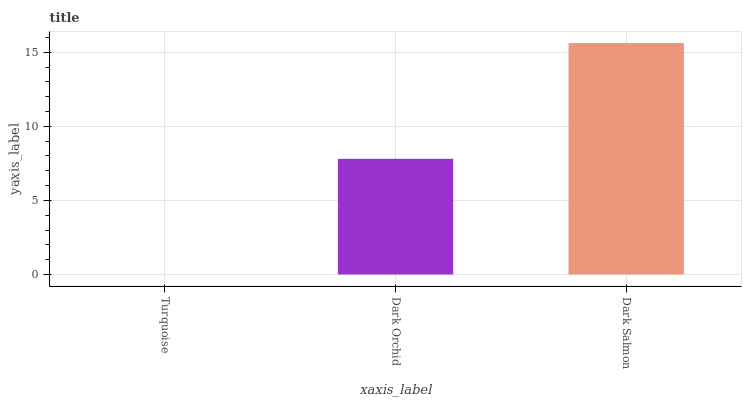Is Dark Orchid the minimum?
Answer yes or no. No. Is Dark Orchid the maximum?
Answer yes or no. No. Is Dark Orchid greater than Turquoise?
Answer yes or no. Yes. Is Turquoise less than Dark Orchid?
Answer yes or no. Yes. Is Turquoise greater than Dark Orchid?
Answer yes or no. No. Is Dark Orchid less than Turquoise?
Answer yes or no. No. Is Dark Orchid the high median?
Answer yes or no. Yes. Is Dark Orchid the low median?
Answer yes or no. Yes. Is Turquoise the high median?
Answer yes or no. No. Is Dark Salmon the low median?
Answer yes or no. No. 